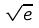Convert formula to latex. <formula><loc_0><loc_0><loc_500><loc_500>\sqrt { e }</formula> 